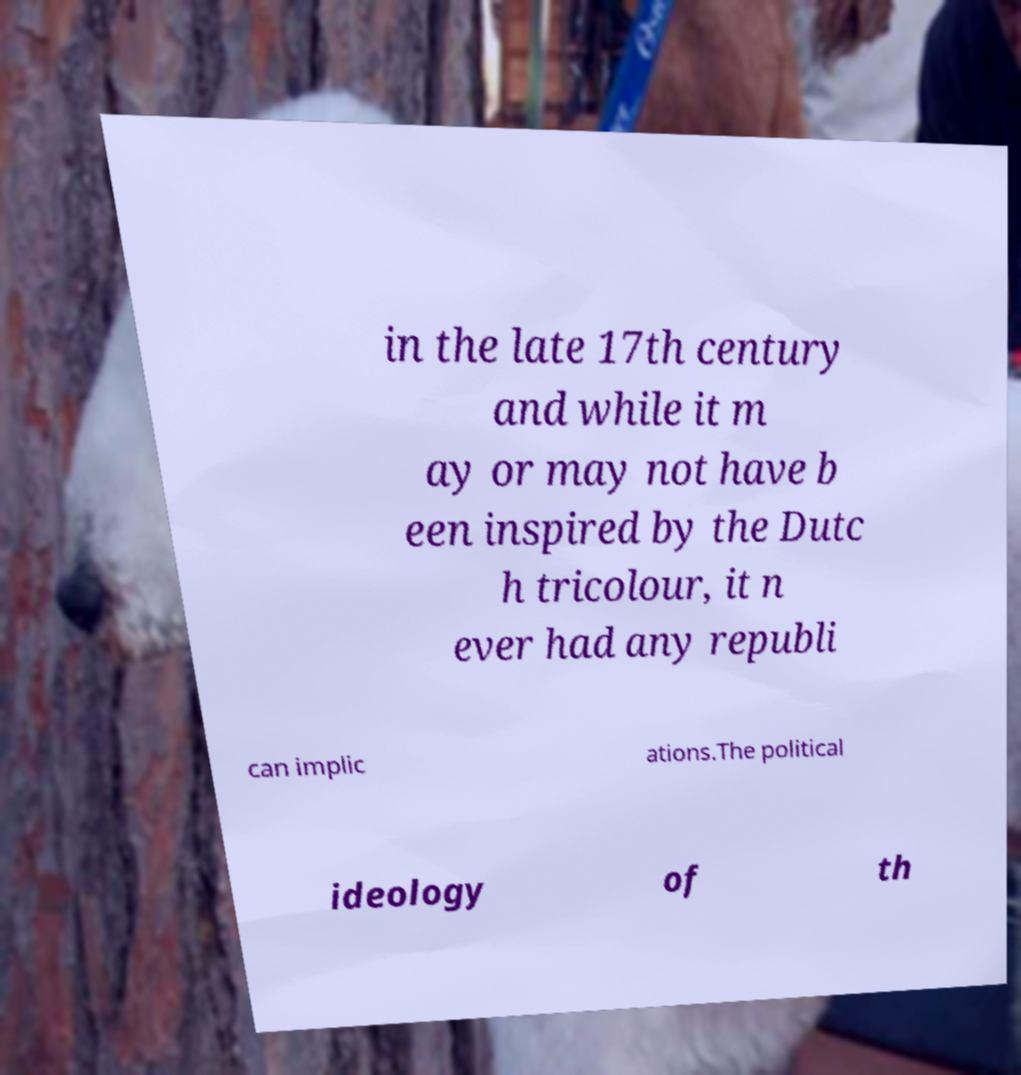Please read and relay the text visible in this image. What does it say? in the late 17th century and while it m ay or may not have b een inspired by the Dutc h tricolour, it n ever had any republi can implic ations.The political ideology of th 